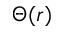Convert formula to latex. <formula><loc_0><loc_0><loc_500><loc_500>\Theta ( r )</formula> 